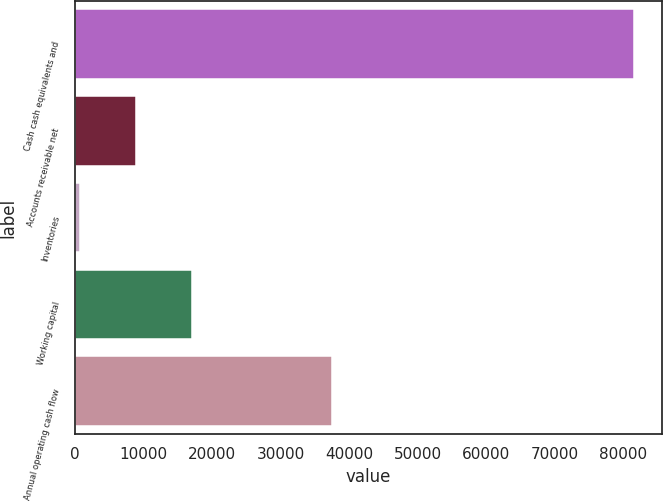Convert chart. <chart><loc_0><loc_0><loc_500><loc_500><bar_chart><fcel>Cash cash equivalents and<fcel>Accounts receivable net<fcel>Inventories<fcel>Working capital<fcel>Annual operating cash flow<nl><fcel>81570<fcel>8855.4<fcel>776<fcel>17018<fcel>37529<nl></chart> 